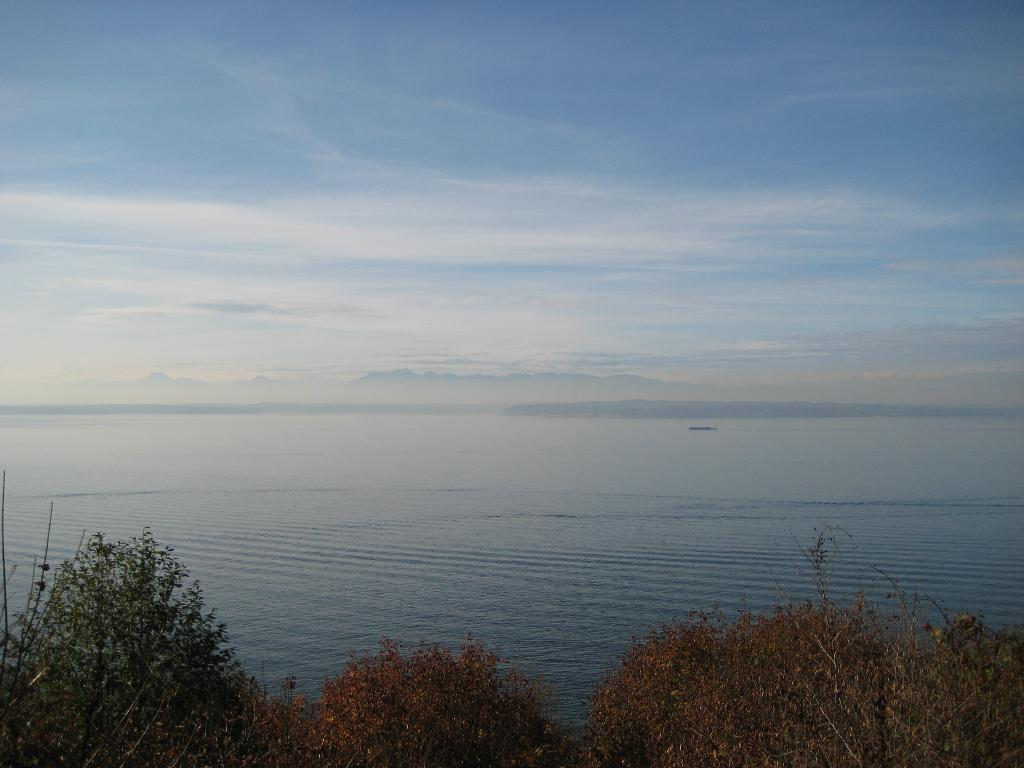What type of vegetation can be seen in the image? There are trees in the image. What natural element is visible in the image besides the trees? There is water visible in the image. How would you describe the sky in the image? The sky is blue and cloudy in the image. What type of trucks can be seen transporting eggnog in the image? There are no trucks or eggnog present in the image. 